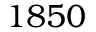Convert formula to latex. <formula><loc_0><loc_0><loc_500><loc_500>1 8 5 0</formula> 